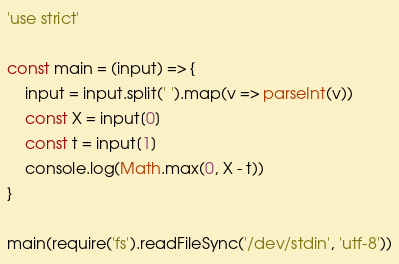<code> <loc_0><loc_0><loc_500><loc_500><_JavaScript_>'use strict'

const main = (input) => {
    input = input.split(' ').map(v => parseInt(v))
    const X = input[0]
    const t = input[1]
    console.log(Math.max(0, X - t))
}

main(require('fs').readFileSync('/dev/stdin', 'utf-8'))</code> 